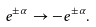<formula> <loc_0><loc_0><loc_500><loc_500>e ^ { \pm \alpha } \rightarrow - e ^ { \pm \alpha } .</formula> 